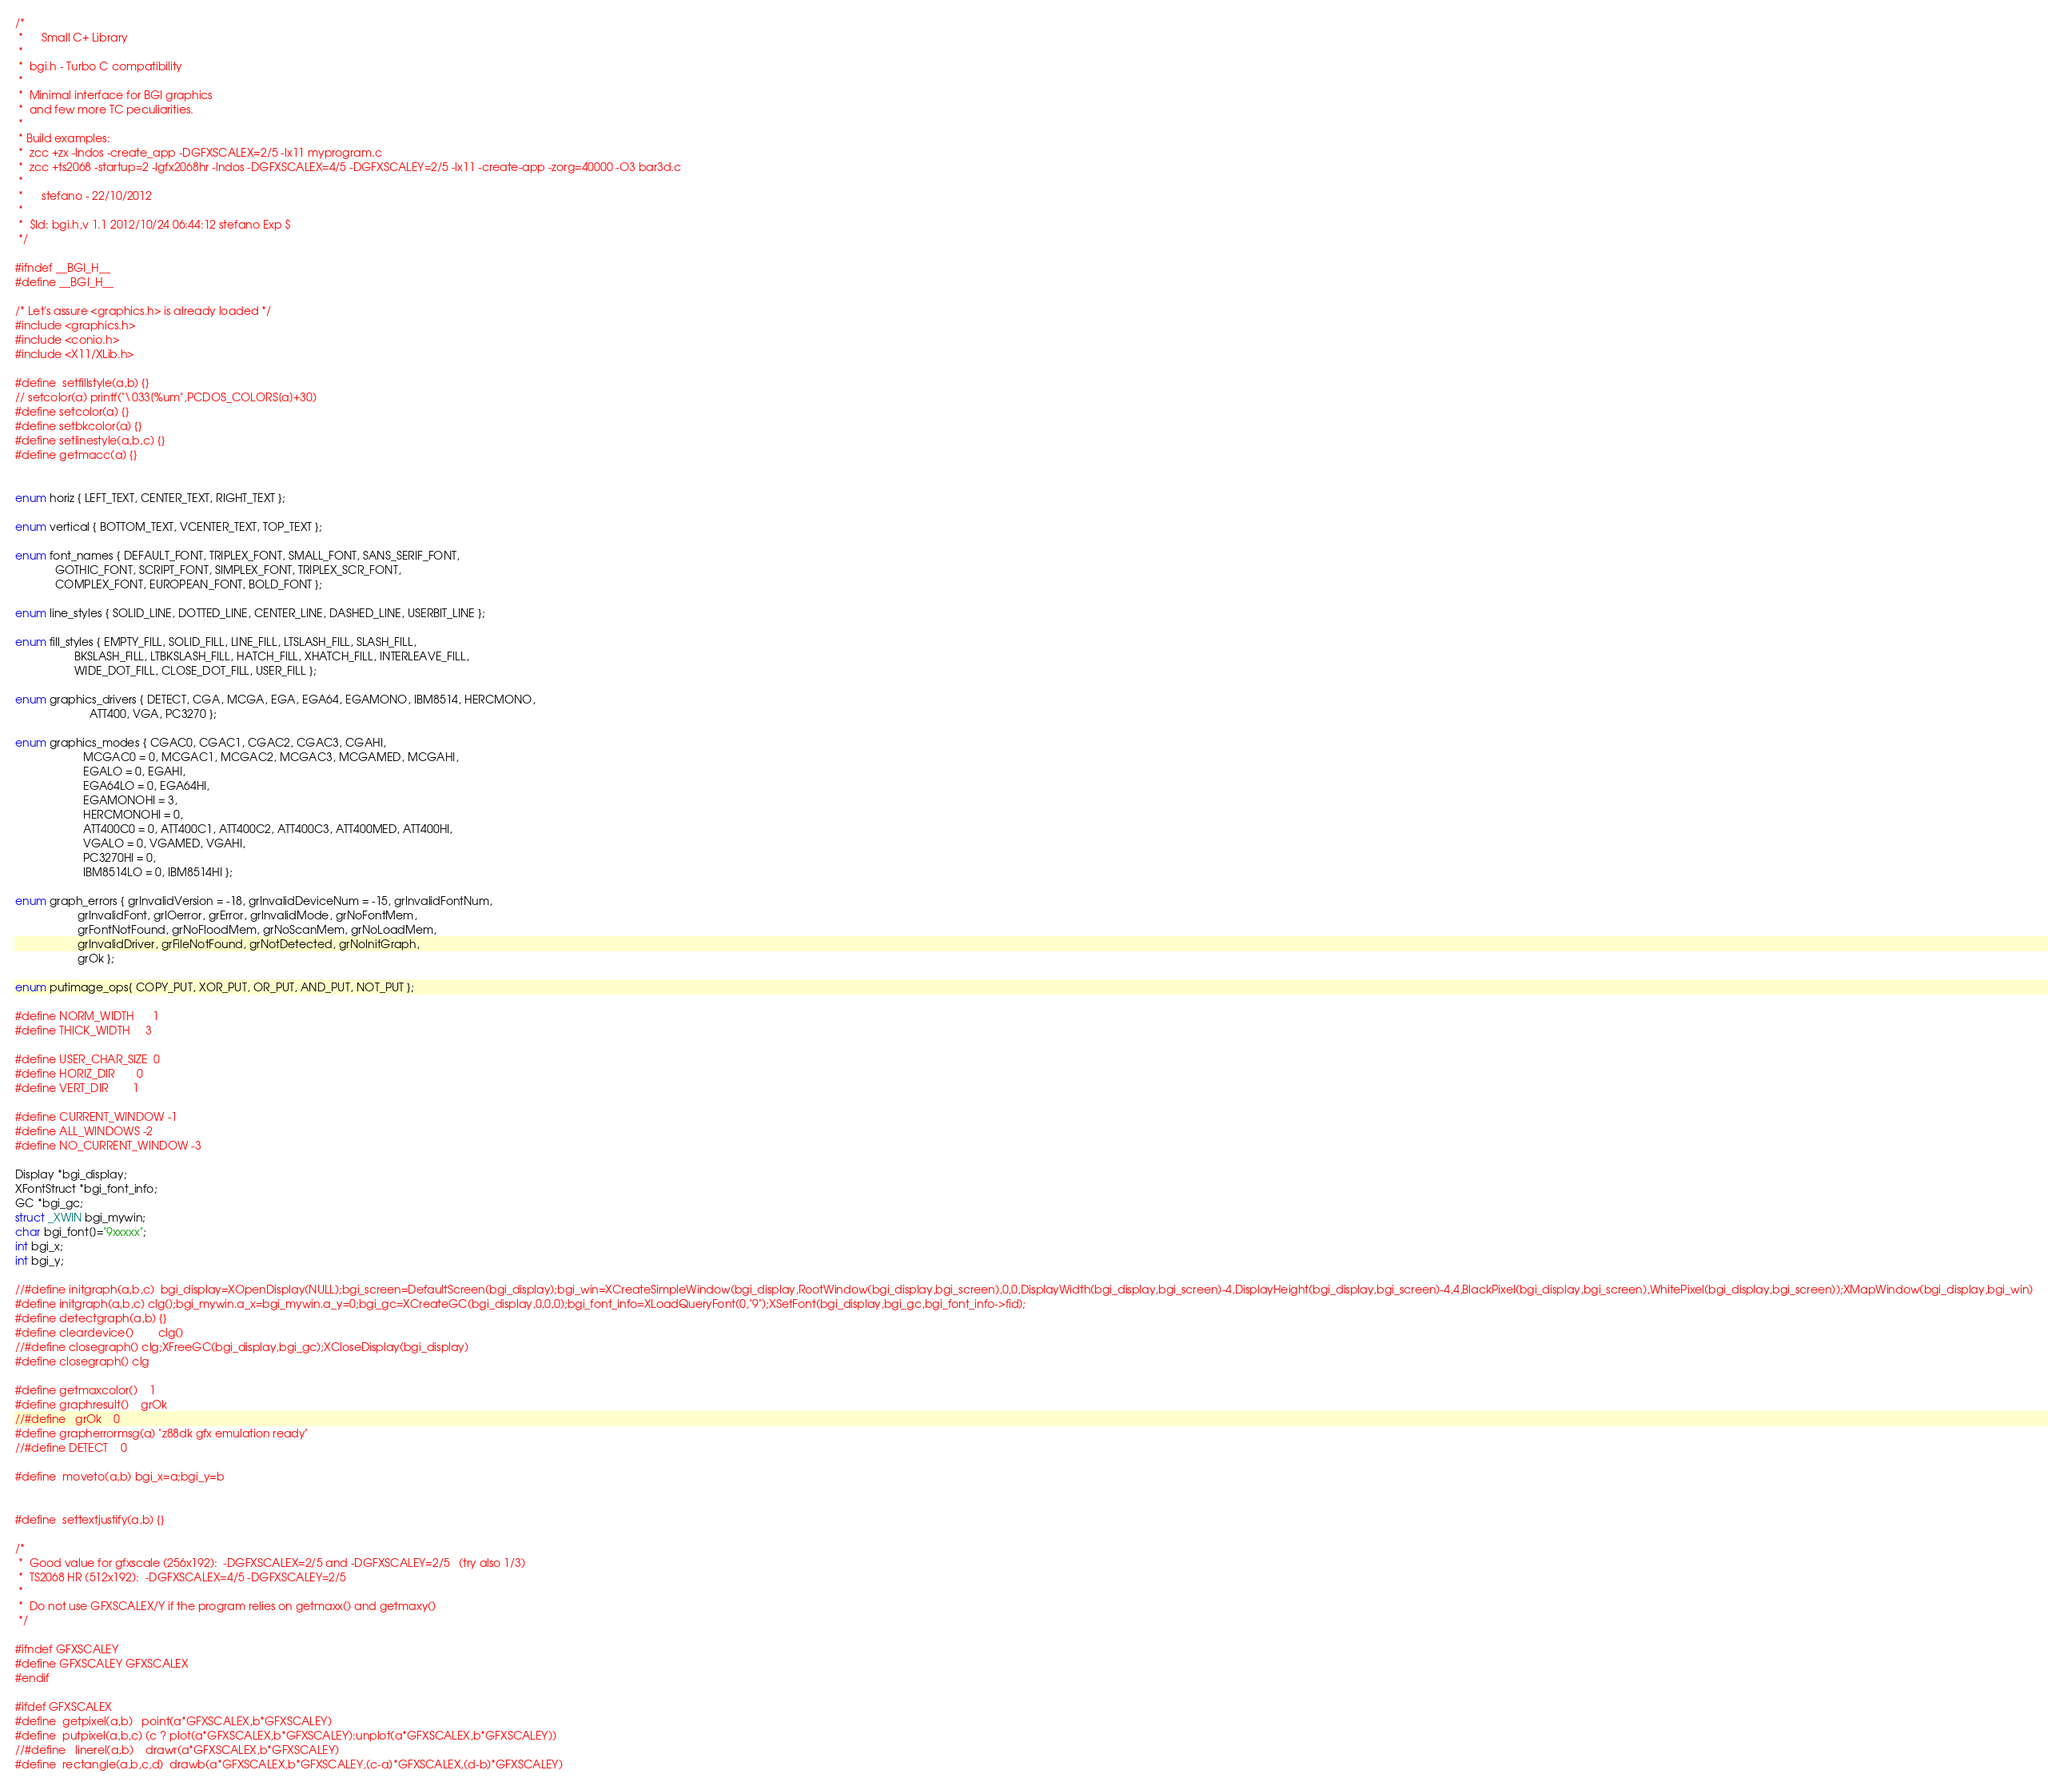<code> <loc_0><loc_0><loc_500><loc_500><_C_>/*
 *      Small C+ Library
 *
 *  bgi.h - Turbo C compatibility
 * 
 *	Minimal interface for BGI graphics
 *	and few more TC peculiarities.
 * 
 * Build examples:
 *  zcc +zx -lndos -create_app -DGFXSCALEX=2/5 -lx11 myprogram.c
 *  zcc +ts2068 -startup=2 -lgfx2068hr -lndos -DGFXSCALEX=4/5 -DGFXSCALEY=2/5 -lx11 -create-app -zorg=40000 -O3 bar3d.c
 *
 *      stefano - 22/10/2012
 *
 *	$Id: bgi.h,v 1.1 2012/10/24 06:44:12 stefano Exp $
 */

#ifndef __BGI_H__
#define __BGI_H__

/* Let's assure <graphics.h> is already loaded */
#include <graphics.h>
#include <conio.h>
#include <X11/XLib.h>

#define	setfillstyle(a,b) {}
// setcolor(a) printf("\033[%um",PCDOS_COLORS[a]+30)
#define setcolor(a) {}
#define setbkcolor(a) {}
#define setlinestyle(a,b,c) {}
#define getmacc(a) {}


enum horiz { LEFT_TEXT, CENTER_TEXT, RIGHT_TEXT };

enum vertical { BOTTOM_TEXT, VCENTER_TEXT, TOP_TEXT };

enum font_names { DEFAULT_FONT, TRIPLEX_FONT, SMALL_FONT, SANS_SERIF_FONT,
             GOTHIC_FONT, SCRIPT_FONT, SIMPLEX_FONT, TRIPLEX_SCR_FONT,
			 COMPLEX_FONT, EUROPEAN_FONT, BOLD_FONT };

enum line_styles { SOLID_LINE, DOTTED_LINE, CENTER_LINE, DASHED_LINE, USERBIT_LINE };

enum fill_styles { EMPTY_FILL, SOLID_FILL, LINE_FILL, LTSLASH_FILL, SLASH_FILL,
                   BKSLASH_FILL, LTBKSLASH_FILL, HATCH_FILL, XHATCH_FILL, INTERLEAVE_FILL,
                   WIDE_DOT_FILL, CLOSE_DOT_FILL, USER_FILL };

enum graphics_drivers { DETECT, CGA, MCGA, EGA, EGA64, EGAMONO, IBM8514, HERCMONO,
                        ATT400, VGA, PC3270 };

enum graphics_modes { CGAC0, CGAC1, CGAC2, CGAC3, CGAHI, 
                      MCGAC0 = 0, MCGAC1, MCGAC2, MCGAC3, MCGAMED, MCGAHI,
                      EGALO = 0, EGAHI,
                      EGA64LO = 0, EGA64HI,
                      EGAMONOHI = 3,
                      HERCMONOHI = 0,
                      ATT400C0 = 0, ATT400C1, ATT400C2, ATT400C3, ATT400MED, ATT400HI,
                      VGALO = 0, VGAMED, VGAHI,
                      PC3270HI = 0,
                      IBM8514LO = 0, IBM8514HI };

enum graph_errors { grInvalidVersion = -18, grInvalidDeviceNum = -15, grInvalidFontNum,
                    grInvalidFont, grIOerror, grError, grInvalidMode, grNoFontMem,
                    grFontNotFound, grNoFloodMem, grNoScanMem, grNoLoadMem,
                    grInvalidDriver, grFileNotFound, grNotDetected, grNoInitGraph,
                    grOk };

enum putimage_ops{ COPY_PUT, XOR_PUT, OR_PUT, AND_PUT, NOT_PUT };

#define NORM_WIDTH      1
#define THICK_WIDTH     3

#define USER_CHAR_SIZE  0
#define HORIZ_DIR       0
#define VERT_DIR        1

#define CURRENT_WINDOW -1
#define ALL_WINDOWS -2
#define NO_CURRENT_WINDOW -3

Display *bgi_display;
XFontStruct *bgi_font_info;
GC *bgi_gc;
struct _XWIN bgi_mywin;
char bgi_font[]="9xxxxx";
int bgi_x;
int bgi_y;

//#define initgraph(a,b,c)	bgi_display=XOpenDisplay(NULL);bgi_screen=DefaultScreen(bgi_display);bgi_win=XCreateSimpleWindow(bgi_display,RootWindow(bgi_display,bgi_screen),0,0,DisplayWidth(bgi_display,bgi_screen)-4,DisplayHeight(bgi_display,bgi_screen)-4,4,BlackPixel(bgi_display,bgi_screen),WhitePixel(bgi_display,bgi_screen));XMapWindow(bgi_display,bgi_win)
#define initgraph(a,b,c)	clg();bgi_mywin.a_x=bgi_mywin.a_y=0;bgi_gc=XCreateGC(bgi_display,0,0,0);bgi_font_info=XLoadQueryFont(0,"9");XSetFont(bgi_display,bgi_gc,bgi_font_info->fid);
#define detectgraph(a,b)	{}
#define cleardevice()		clg()
//#define closegraph() clg;XFreeGC(bgi_display,bgi_gc);XCloseDisplay(bgi_display)
#define closegraph() clg

#define getmaxcolor()	1
#define graphresult()	grOk
//#define	grOk	0
#define grapherrormsg(a) "z88dk gfx emulation ready"
//#define DETECT	0

#define	moveto(a,b) bgi_x=a;bgi_y=b


#define	settextjustify(a,b)	{}

/* 
 *  Good value for gfxscale (256x192):  -DGFXSCALEX=2/5 and -DGFXSCALEY=2/5   (try also 1/3)
 *  TS2068 HR (512x192):  -DGFXSCALEX=4/5 -DGFXSCALEY=2/5
 * 
 *  Do not use GFXSCALEX/Y if the program relies on getmaxx() and getmaxy()
 */

#ifndef GFXSCALEY
#define GFXSCALEY GFXSCALEX
#endif

#ifdef GFXSCALEX
#define	getpixel(a,b)	point(a*GFXSCALEX,b*GFXSCALEY)
#define	putpixel(a,b,c)	(c ? plot(a*GFXSCALEX,b*GFXSCALEY):unplot(a*GFXSCALEX,b*GFXSCALEY))
//#define	linerel(a,b)	drawr(a*GFXSCALEX,b*GFXSCALEY)
#define	rectangle(a,b,c,d)	drawb(a*GFXSCALEX,b*GFXSCALEY,(c-a)*GFXSCALEX,(d-b)*GFXSCALEY)</code> 